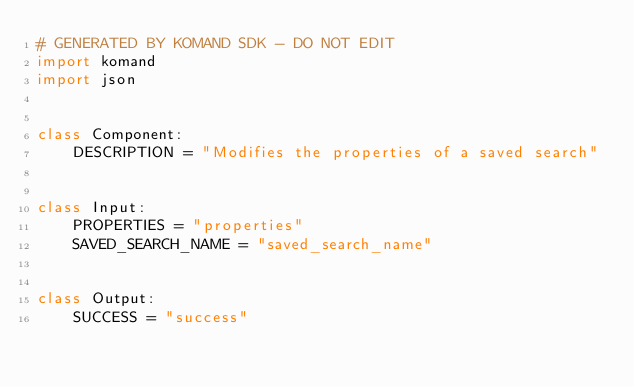<code> <loc_0><loc_0><loc_500><loc_500><_Python_># GENERATED BY KOMAND SDK - DO NOT EDIT
import komand
import json


class Component:
    DESCRIPTION = "Modifies the properties of a saved search"


class Input:
    PROPERTIES = "properties"
    SAVED_SEARCH_NAME = "saved_search_name"
    

class Output:
    SUCCESS = "success"
    
</code> 